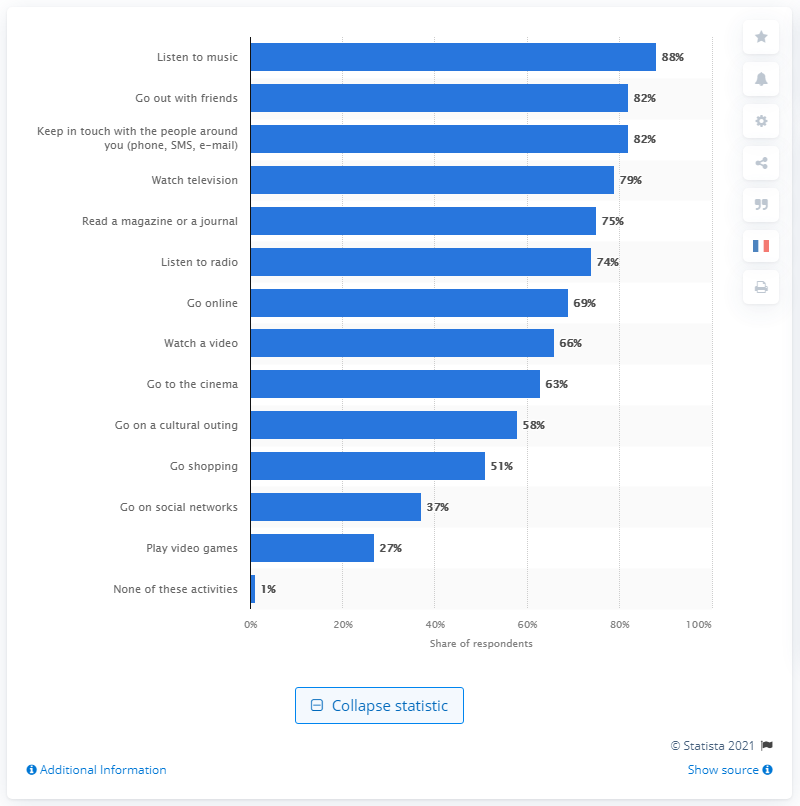Identify some key points in this picture. In 2015, the penetration rate of listening to music was 88%. This means that 88% of the population was actively engaging in listening to music during that year. 